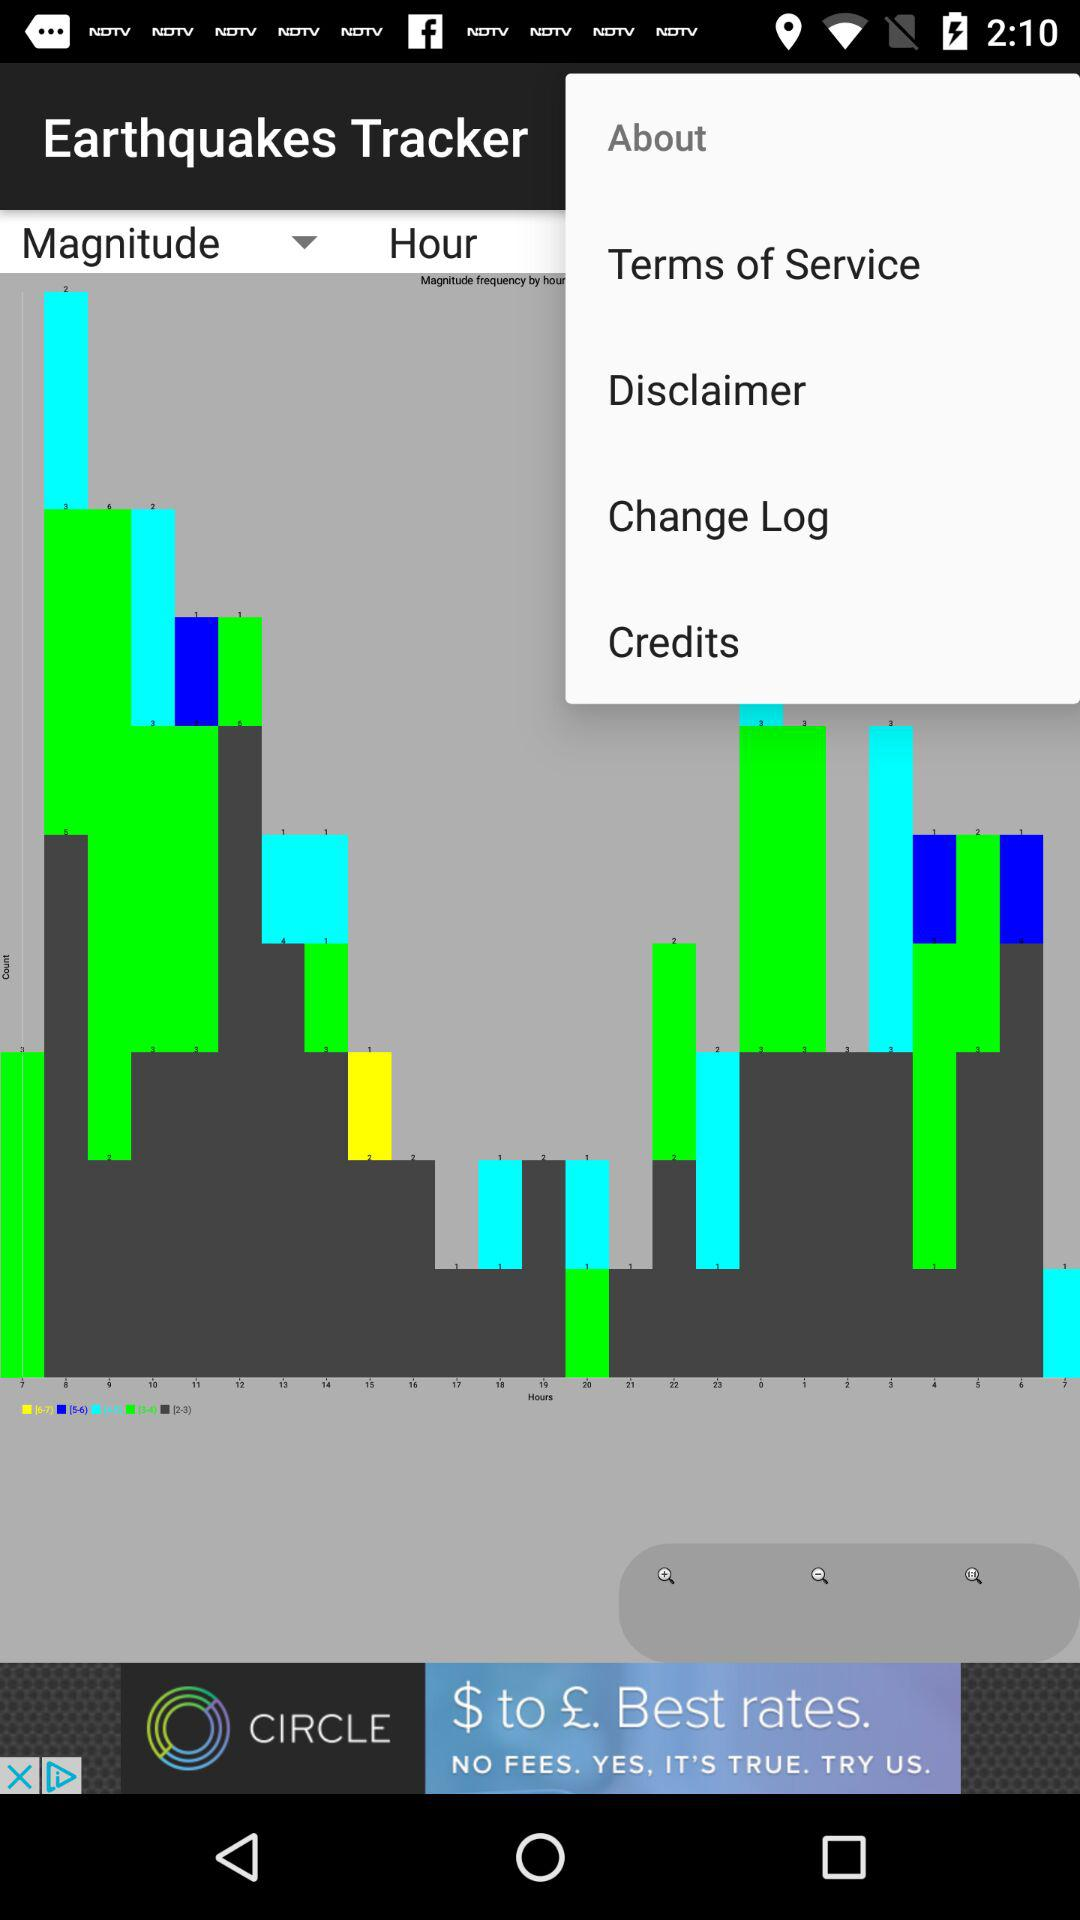What is the application name? The application name is "Earthquakes Tracker". 